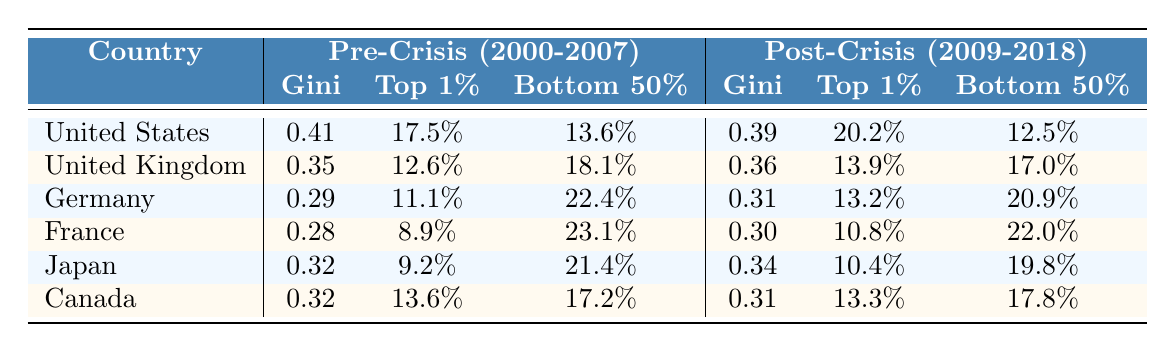What was the Gini coefficient in the United States before the 2008 financial crisis? The Gini coefficient for the United States in the Pre-Crisis period (2000-2007) is listed in the table. It shows a value of 0.41.
Answer: 0.41 What was the income share of the top 1% in Germany after the financial crisis? The table indicates the top 1% income share in Germany during the Post-Crisis period (2009-2018) is 13.2%.
Answer: 13.2% Which country had the lowest Gini coefficient before the crisis? By comparing the Gini coefficients listed in the table for each country before the crisis, France has the lowest value at 0.28.
Answer: France Did the bottom 50% income share increase or decrease in the United Kingdom after the crisis? The table shows that the bottom 50% income share in the UK was 18.1% before the crisis and decreased to 17.0% after the crisis, indicating a decrease.
Answer: Decrease What was the average Gini coefficient across all countries in the Pre-Crisis period? To find the average Gini coefficient, I will sum the coefficients: 0.41 (US) + 0.35 (UK) + 0.29 (Germany) + 0.28 (France) + 0.32 (Japan) + 0.32 (Canada) = 2.36. Dividing by 6 (the number of countries) results in 2.36 / 6 = 0.39333, which rounds to 0.39.
Answer: 0.39 Is the top 1% income share in the United States higher after the financial crisis? The table indicates that the top 1% income share in the US rose from 17.5% before the crisis to 20.2% after, confirming that it is higher after the crisis.
Answer: Yes By how much did the bottom 50% income share change in France from Pre-Crisis to Post-Crisis? The bottom 50% income share in France was 23.1% before the crisis and 22.0% after. The change is 23.1% - 22.0% = 1.1%, indicating a decrease.
Answer: Decrease by 1.1% Which country saw an increase in both the Gini coefficient and the top 1% income share after the crisis? By examining the data, the United States shows an increase in both measures: the Gini coefficient rose from 0.41 to 0.39, and the top 1% income share increased from 17.5% to 20.2%.
Answer: United States What is the percentage difference in the top 1% income share before and after the crisis in Canada? The top 1% income share in Canada went from 13.6% to 13.3%. The difference is 13.6% - 13.3% = 0.3%. The percentage difference relative to the pre-crisis share is (0.3% / 13.6%) * 100 = 2.205%, indicating a decrease.
Answer: Decrease by 2.205% After the financial crisis, was the bottom 50% income share in Japan higher than in Canada? The table shows that in Japan the bottom 50% income share was 19.8% and in Canada 17.8%. Since 19.8% is higher than 17.8%, the share in Japan is indeed higher.
Answer: Yes 